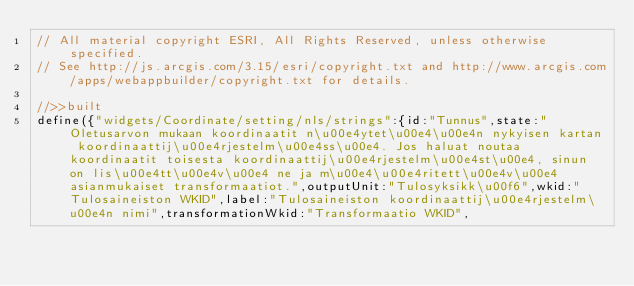<code> <loc_0><loc_0><loc_500><loc_500><_JavaScript_>// All material copyright ESRI, All Rights Reserved, unless otherwise specified.
// See http://js.arcgis.com/3.15/esri/copyright.txt and http://www.arcgis.com/apps/webappbuilder/copyright.txt for details.
//>>built
define({"widgets/Coordinate/setting/nls/strings":{id:"Tunnus",state:"Oletusarvon mukaan koordinaatit n\u00e4ytet\u00e4\u00e4n nykyisen kartan koordinaattij\u00e4rjestelm\u00e4ss\u00e4. Jos haluat noutaa koordinaatit toisesta koordinaattij\u00e4rjestelm\u00e4st\u00e4, sinun on lis\u00e4tt\u00e4v\u00e4 ne ja m\u00e4\u00e4ritett\u00e4v\u00e4 asianmukaiset transformaatiot.",outputUnit:"Tulosyksikk\u00f6",wkid:"Tulosaineiston WKID",label:"Tulosaineiston koordinaattij\u00e4rjestelm\u00e4n nimi",transformationWkid:"Transformaatio WKID",</code> 